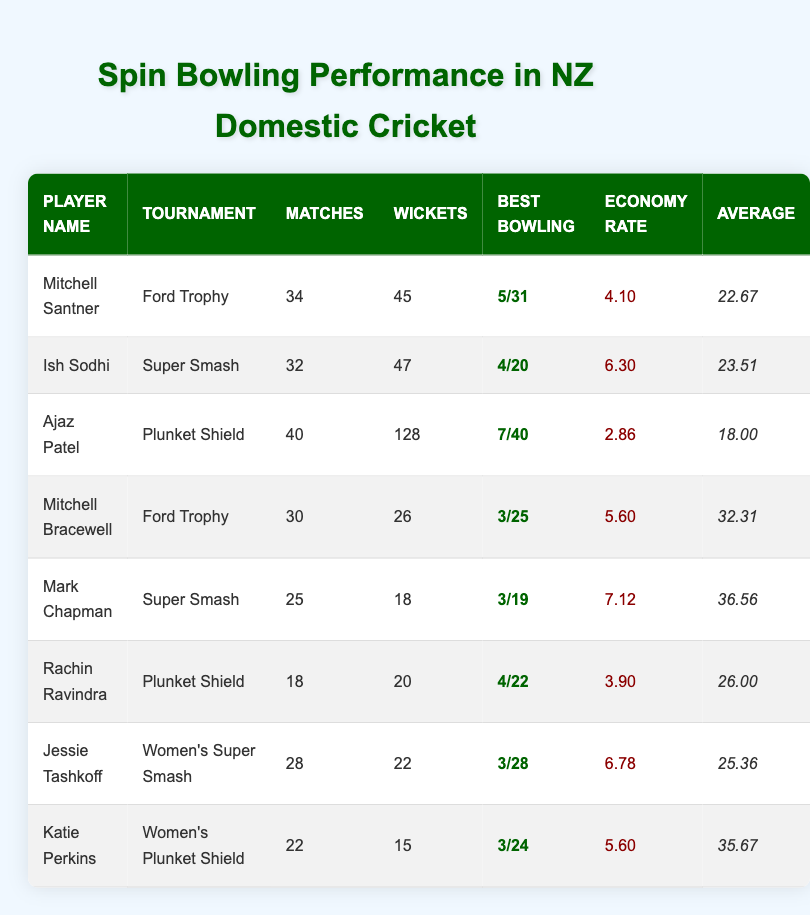What is the best bowling performance of Ajaz Patel? In the table, Ajaz Patel's best bowling performance is listed as "7/40".
Answer: 7/40 How many wickets did Mitchell Santner take in the Ford Trophy? According to the table, Mitchell Santner took 45 wickets in the Ford Trophy.
Answer: 45 Which player has the lowest economy rate and what is it? By reviewing the table, Ajaz Patel has the lowest economy rate at 2.86.
Answer: 2.86 What is the total number of wickets taken by all players in the Plunket Shield? The total wickets taken by players in the Plunket Shield is calculated by adding Ajaz Patel's 128 wickets and Rachin Ravindra's 20 wickets, giving a total of 148 wickets.
Answer: 148 Did Rachin Ravindra take more wickets than Mark Chapman? Rachin Ravindra took 20 wickets while Mark Chapman took 18 wickets, meaning Rachin Ravindra took more.
Answer: Yes What is the average wickets taken by players in the Women's Plunket Shield and Super Smash? The average is calculated by taking Katie Perkins’ 15 wickets in the Women's Plunket Shield and Jessie Tashkoff's 22 wickets in the Women's Super Smash, summing them gives 37, then dividing by 2 results in an average of 18.5.
Answer: 18.5 How many matches did Ish Sodhi play compared to Mitchell Bracewell? Ish Sodhi played 32 matches while Mitchell Bracewell played 30 matches, meaning Ish Sodhi played 2 more matches.
Answer: 2 more matches Who took the most wickets overall in the provided tournaments? By comparing the wickets, Ajaz Patel took the most wickets, totaling 128, which is higher than any other player.
Answer: Ajaz Patel What is the difference in average between Mitchell Bracewell and Mitchell Santner? Mitchell Bracewell has an average of 32.31 and Mitchell Santner has an average of 22.67, calculating the difference gives 32.31 - 22.67 = 9.64.
Answer: 9.64 Which tournament did Jessie Tashkoff compete in, and how many wickets did she take? Jessie Tashkoff played in the Women's Super Smash and took 22 wickets as per the table.
Answer: Women's Super Smash, 22 wickets 